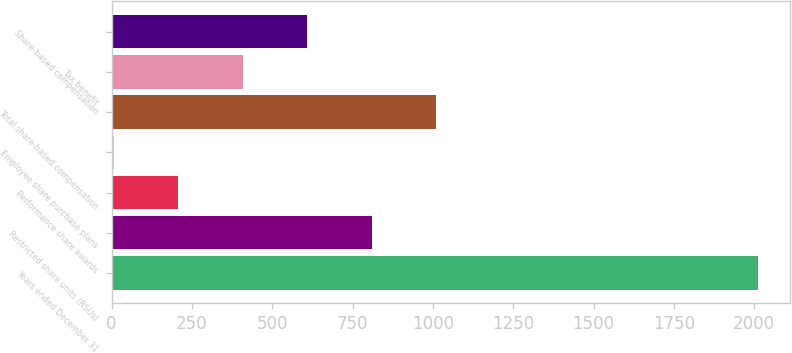Convert chart to OTSL. <chart><loc_0><loc_0><loc_500><loc_500><bar_chart><fcel>Years ended December 31<fcel>Restricted share units (RSUs)<fcel>Performance share awards<fcel>Employee share purchase plans<fcel>Total share-based compensation<fcel>Tax benefit<fcel>Share-based compensation<nl><fcel>2012<fcel>809<fcel>207.5<fcel>7<fcel>1009.5<fcel>408<fcel>608.5<nl></chart> 